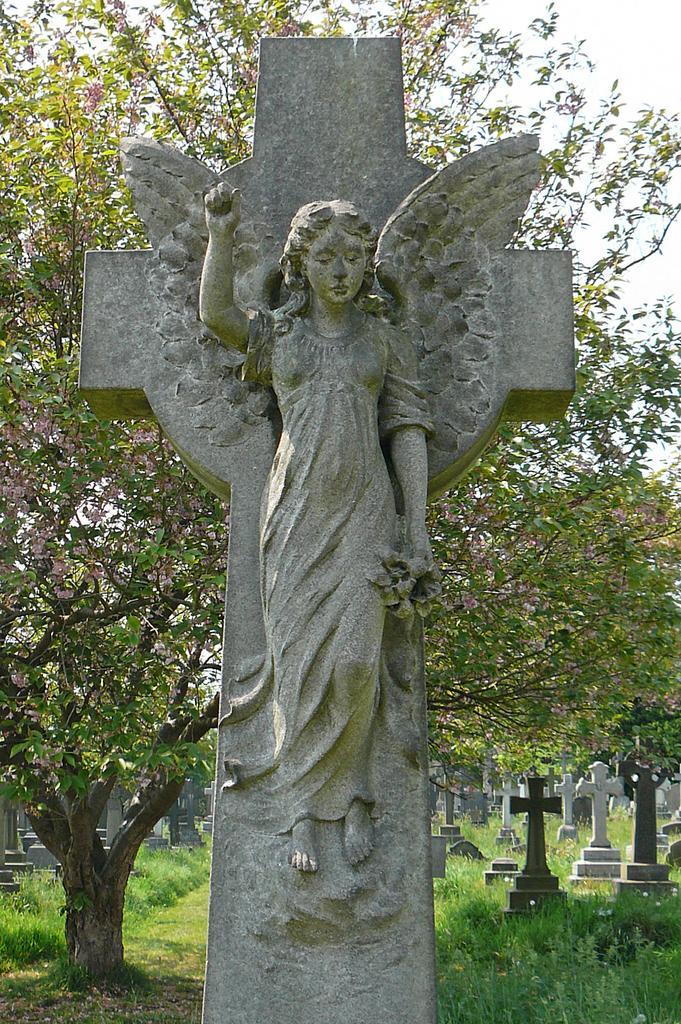Can you describe this image briefly? In the center of the image there is a concrete angel structure. At the bottom of the image there is grass on the surface. There are headstones. There are trees and in background of the image there is sky. 